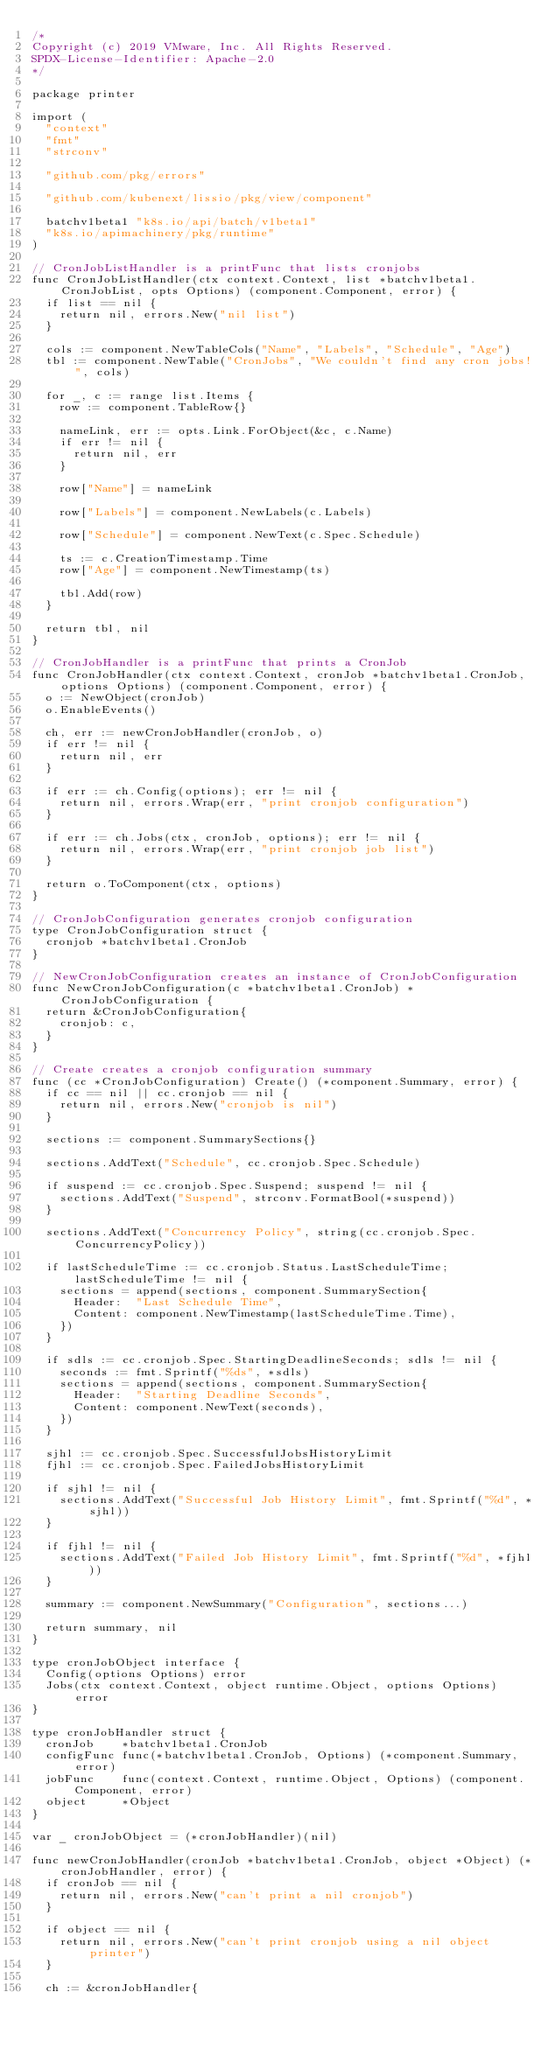<code> <loc_0><loc_0><loc_500><loc_500><_Go_>/*
Copyright (c) 2019 VMware, Inc. All Rights Reserved.
SPDX-License-Identifier: Apache-2.0
*/

package printer

import (
	"context"
	"fmt"
	"strconv"

	"github.com/pkg/errors"

	"github.com/kubenext/lissio/pkg/view/component"

	batchv1beta1 "k8s.io/api/batch/v1beta1"
	"k8s.io/apimachinery/pkg/runtime"
)

// CronJobListHandler is a printFunc that lists cronjobs
func CronJobListHandler(ctx context.Context, list *batchv1beta1.CronJobList, opts Options) (component.Component, error) {
	if list == nil {
		return nil, errors.New("nil list")
	}

	cols := component.NewTableCols("Name", "Labels", "Schedule", "Age")
	tbl := component.NewTable("CronJobs", "We couldn't find any cron jobs!", cols)

	for _, c := range list.Items {
		row := component.TableRow{}

		nameLink, err := opts.Link.ForObject(&c, c.Name)
		if err != nil {
			return nil, err
		}

		row["Name"] = nameLink

		row["Labels"] = component.NewLabels(c.Labels)

		row["Schedule"] = component.NewText(c.Spec.Schedule)

		ts := c.CreationTimestamp.Time
		row["Age"] = component.NewTimestamp(ts)

		tbl.Add(row)
	}

	return tbl, nil
}

// CronJobHandler is a printFunc that prints a CronJob
func CronJobHandler(ctx context.Context, cronJob *batchv1beta1.CronJob, options Options) (component.Component, error) {
	o := NewObject(cronJob)
	o.EnableEvents()

	ch, err := newCronJobHandler(cronJob, o)
	if err != nil {
		return nil, err
	}

	if err := ch.Config(options); err != nil {
		return nil, errors.Wrap(err, "print cronjob configuration")
	}

	if err := ch.Jobs(ctx, cronJob, options); err != nil {
		return nil, errors.Wrap(err, "print cronjob job list")
	}

	return o.ToComponent(ctx, options)
}

// CronJobConfiguration generates cronjob configuration
type CronJobConfiguration struct {
	cronjob *batchv1beta1.CronJob
}

// NewCronJobConfiguration creates an instance of CronJobConfiguration
func NewCronJobConfiguration(c *batchv1beta1.CronJob) *CronJobConfiguration {
	return &CronJobConfiguration{
		cronjob: c,
	}
}

// Create creates a cronjob configuration summary
func (cc *CronJobConfiguration) Create() (*component.Summary, error) {
	if cc == nil || cc.cronjob == nil {
		return nil, errors.New("cronjob is nil")
	}

	sections := component.SummarySections{}

	sections.AddText("Schedule", cc.cronjob.Spec.Schedule)

	if suspend := cc.cronjob.Spec.Suspend; suspend != nil {
		sections.AddText("Suspend", strconv.FormatBool(*suspend))
	}

	sections.AddText("Concurrency Policy", string(cc.cronjob.Spec.ConcurrencyPolicy))

	if lastScheduleTime := cc.cronjob.Status.LastScheduleTime; lastScheduleTime != nil {
		sections = append(sections, component.SummarySection{
			Header:  "Last Schedule Time",
			Content: component.NewTimestamp(lastScheduleTime.Time),
		})
	}

	if sdls := cc.cronjob.Spec.StartingDeadlineSeconds; sdls != nil {
		seconds := fmt.Sprintf("%ds", *sdls)
		sections = append(sections, component.SummarySection{
			Header:  "Starting Deadline Seconds",
			Content: component.NewText(seconds),
		})
	}

	sjhl := cc.cronjob.Spec.SuccessfulJobsHistoryLimit
	fjhl := cc.cronjob.Spec.FailedJobsHistoryLimit

	if sjhl != nil {
		sections.AddText("Successful Job History Limit", fmt.Sprintf("%d", *sjhl))
	}

	if fjhl != nil {
		sections.AddText("Failed Job History Limit", fmt.Sprintf("%d", *fjhl))
	}

	summary := component.NewSummary("Configuration", sections...)

	return summary, nil
}

type cronJobObject interface {
	Config(options Options) error
	Jobs(ctx context.Context, object runtime.Object, options Options) error
}

type cronJobHandler struct {
	cronJob    *batchv1beta1.CronJob
	configFunc func(*batchv1beta1.CronJob, Options) (*component.Summary, error)
	jobFunc    func(context.Context, runtime.Object, Options) (component.Component, error)
	object     *Object
}

var _ cronJobObject = (*cronJobHandler)(nil)

func newCronJobHandler(cronJob *batchv1beta1.CronJob, object *Object) (*cronJobHandler, error) {
	if cronJob == nil {
		return nil, errors.New("can't print a nil cronjob")
	}

	if object == nil {
		return nil, errors.New("can't print cronjob using a nil object printer")
	}

	ch := &cronJobHandler{</code> 